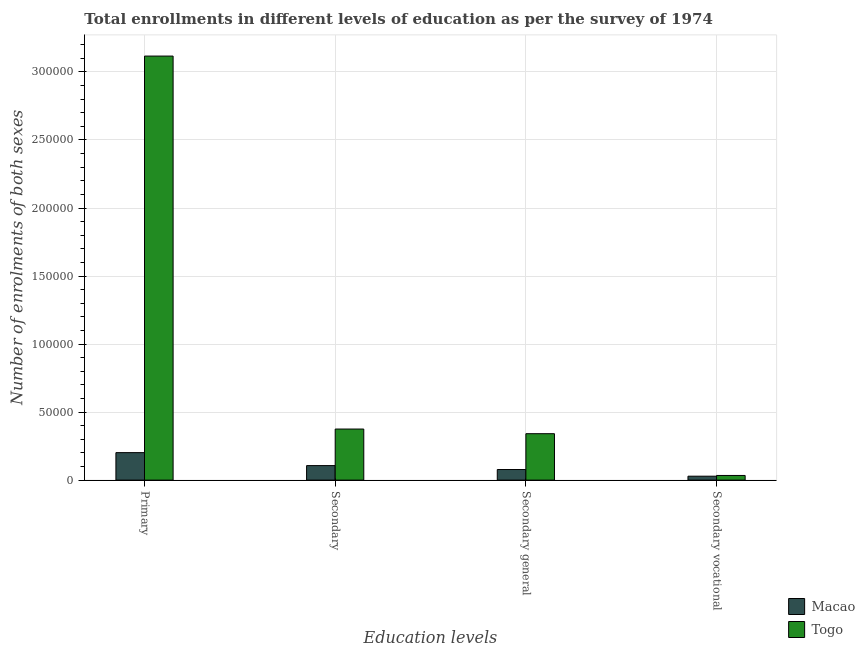How many groups of bars are there?
Offer a terse response. 4. Are the number of bars per tick equal to the number of legend labels?
Ensure brevity in your answer.  Yes. How many bars are there on the 4th tick from the right?
Keep it short and to the point. 2. What is the label of the 2nd group of bars from the left?
Your answer should be compact. Secondary. What is the number of enrolments in secondary vocational education in Togo?
Your answer should be very brief. 3421. Across all countries, what is the maximum number of enrolments in secondary vocational education?
Provide a short and direct response. 3421. Across all countries, what is the minimum number of enrolments in secondary education?
Your answer should be very brief. 1.07e+04. In which country was the number of enrolments in secondary education maximum?
Your answer should be compact. Togo. In which country was the number of enrolments in secondary general education minimum?
Give a very brief answer. Macao. What is the total number of enrolments in secondary education in the graph?
Provide a succinct answer. 4.82e+04. What is the difference between the number of enrolments in primary education in Macao and that in Togo?
Your answer should be very brief. -2.91e+05. What is the difference between the number of enrolments in secondary general education in Macao and the number of enrolments in secondary education in Togo?
Offer a terse response. -2.98e+04. What is the average number of enrolments in secondary vocational education per country?
Your answer should be compact. 3153. What is the difference between the number of enrolments in primary education and number of enrolments in secondary vocational education in Togo?
Give a very brief answer. 3.08e+05. In how many countries, is the number of enrolments in secondary vocational education greater than 270000 ?
Offer a very short reply. 0. What is the ratio of the number of enrolments in secondary vocational education in Macao to that in Togo?
Your response must be concise. 0.84. Is the number of enrolments in secondary general education in Togo less than that in Macao?
Keep it short and to the point. No. Is the difference between the number of enrolments in secondary general education in Macao and Togo greater than the difference between the number of enrolments in primary education in Macao and Togo?
Your answer should be compact. Yes. What is the difference between the highest and the second highest number of enrolments in secondary education?
Offer a terse response. 2.69e+04. What is the difference between the highest and the lowest number of enrolments in secondary general education?
Ensure brevity in your answer.  2.63e+04. What does the 2nd bar from the left in Primary represents?
Keep it short and to the point. Togo. What does the 2nd bar from the right in Secondary vocational represents?
Provide a short and direct response. Macao. Does the graph contain any zero values?
Provide a short and direct response. No. Where does the legend appear in the graph?
Offer a very short reply. Bottom right. How many legend labels are there?
Offer a very short reply. 2. How are the legend labels stacked?
Keep it short and to the point. Vertical. What is the title of the graph?
Keep it short and to the point. Total enrollments in different levels of education as per the survey of 1974. What is the label or title of the X-axis?
Your response must be concise. Education levels. What is the label or title of the Y-axis?
Ensure brevity in your answer.  Number of enrolments of both sexes. What is the Number of enrolments of both sexes in Macao in Primary?
Provide a succinct answer. 2.02e+04. What is the Number of enrolments of both sexes of Togo in Primary?
Your answer should be compact. 3.12e+05. What is the Number of enrolments of both sexes of Macao in Secondary?
Keep it short and to the point. 1.07e+04. What is the Number of enrolments of both sexes of Togo in Secondary?
Keep it short and to the point. 3.75e+04. What is the Number of enrolments of both sexes in Macao in Secondary general?
Provide a short and direct response. 7786. What is the Number of enrolments of both sexes of Togo in Secondary general?
Keep it short and to the point. 3.41e+04. What is the Number of enrolments of both sexes of Macao in Secondary vocational?
Your response must be concise. 2885. What is the Number of enrolments of both sexes of Togo in Secondary vocational?
Give a very brief answer. 3421. Across all Education levels, what is the maximum Number of enrolments of both sexes of Macao?
Provide a succinct answer. 2.02e+04. Across all Education levels, what is the maximum Number of enrolments of both sexes in Togo?
Make the answer very short. 3.12e+05. Across all Education levels, what is the minimum Number of enrolments of both sexes in Macao?
Provide a succinct answer. 2885. Across all Education levels, what is the minimum Number of enrolments of both sexes of Togo?
Give a very brief answer. 3421. What is the total Number of enrolments of both sexes of Macao in the graph?
Your answer should be very brief. 4.15e+04. What is the total Number of enrolments of both sexes of Togo in the graph?
Keep it short and to the point. 3.87e+05. What is the difference between the Number of enrolments of both sexes in Macao in Primary and that in Secondary?
Your answer should be compact. 9534. What is the difference between the Number of enrolments of both sexes of Togo in Primary and that in Secondary?
Give a very brief answer. 2.74e+05. What is the difference between the Number of enrolments of both sexes of Macao in Primary and that in Secondary general?
Offer a very short reply. 1.24e+04. What is the difference between the Number of enrolments of both sexes of Togo in Primary and that in Secondary general?
Provide a succinct answer. 2.78e+05. What is the difference between the Number of enrolments of both sexes in Macao in Primary and that in Secondary vocational?
Ensure brevity in your answer.  1.73e+04. What is the difference between the Number of enrolments of both sexes in Togo in Primary and that in Secondary vocational?
Offer a terse response. 3.08e+05. What is the difference between the Number of enrolments of both sexes of Macao in Secondary and that in Secondary general?
Your response must be concise. 2885. What is the difference between the Number of enrolments of both sexes of Togo in Secondary and that in Secondary general?
Give a very brief answer. 3421. What is the difference between the Number of enrolments of both sexes of Macao in Secondary and that in Secondary vocational?
Give a very brief answer. 7786. What is the difference between the Number of enrolments of both sexes in Togo in Secondary and that in Secondary vocational?
Give a very brief answer. 3.41e+04. What is the difference between the Number of enrolments of both sexes of Macao in Secondary general and that in Secondary vocational?
Offer a very short reply. 4901. What is the difference between the Number of enrolments of both sexes of Togo in Secondary general and that in Secondary vocational?
Keep it short and to the point. 3.07e+04. What is the difference between the Number of enrolments of both sexes in Macao in Primary and the Number of enrolments of both sexes in Togo in Secondary?
Provide a short and direct response. -1.73e+04. What is the difference between the Number of enrolments of both sexes of Macao in Primary and the Number of enrolments of both sexes of Togo in Secondary general?
Your answer should be compact. -1.39e+04. What is the difference between the Number of enrolments of both sexes of Macao in Primary and the Number of enrolments of both sexes of Togo in Secondary vocational?
Offer a terse response. 1.68e+04. What is the difference between the Number of enrolments of both sexes in Macao in Secondary and the Number of enrolments of both sexes in Togo in Secondary general?
Your answer should be compact. -2.35e+04. What is the difference between the Number of enrolments of both sexes of Macao in Secondary and the Number of enrolments of both sexes of Togo in Secondary vocational?
Make the answer very short. 7250. What is the difference between the Number of enrolments of both sexes in Macao in Secondary general and the Number of enrolments of both sexes in Togo in Secondary vocational?
Give a very brief answer. 4365. What is the average Number of enrolments of both sexes of Macao per Education levels?
Provide a succinct answer. 1.04e+04. What is the average Number of enrolments of both sexes of Togo per Education levels?
Your answer should be very brief. 9.67e+04. What is the difference between the Number of enrolments of both sexes of Macao and Number of enrolments of both sexes of Togo in Primary?
Provide a succinct answer. -2.91e+05. What is the difference between the Number of enrolments of both sexes of Macao and Number of enrolments of both sexes of Togo in Secondary?
Offer a terse response. -2.69e+04. What is the difference between the Number of enrolments of both sexes in Macao and Number of enrolments of both sexes in Togo in Secondary general?
Offer a terse response. -2.63e+04. What is the difference between the Number of enrolments of both sexes in Macao and Number of enrolments of both sexes in Togo in Secondary vocational?
Keep it short and to the point. -536. What is the ratio of the Number of enrolments of both sexes in Macao in Primary to that in Secondary?
Your answer should be very brief. 1.89. What is the ratio of the Number of enrolments of both sexes of Togo in Primary to that in Secondary?
Your response must be concise. 8.3. What is the ratio of the Number of enrolments of both sexes of Macao in Primary to that in Secondary general?
Provide a short and direct response. 2.6. What is the ratio of the Number of enrolments of both sexes of Togo in Primary to that in Secondary general?
Your response must be concise. 9.13. What is the ratio of the Number of enrolments of both sexes of Macao in Primary to that in Secondary vocational?
Offer a very short reply. 7. What is the ratio of the Number of enrolments of both sexes in Togo in Primary to that in Secondary vocational?
Provide a succinct answer. 91.11. What is the ratio of the Number of enrolments of both sexes of Macao in Secondary to that in Secondary general?
Your answer should be very brief. 1.37. What is the ratio of the Number of enrolments of both sexes in Togo in Secondary to that in Secondary general?
Give a very brief answer. 1.1. What is the ratio of the Number of enrolments of both sexes in Macao in Secondary to that in Secondary vocational?
Provide a short and direct response. 3.7. What is the ratio of the Number of enrolments of both sexes in Togo in Secondary to that in Secondary vocational?
Make the answer very short. 10.98. What is the ratio of the Number of enrolments of both sexes in Macao in Secondary general to that in Secondary vocational?
Provide a succinct answer. 2.7. What is the ratio of the Number of enrolments of both sexes in Togo in Secondary general to that in Secondary vocational?
Keep it short and to the point. 9.98. What is the difference between the highest and the second highest Number of enrolments of both sexes in Macao?
Make the answer very short. 9534. What is the difference between the highest and the second highest Number of enrolments of both sexes in Togo?
Provide a succinct answer. 2.74e+05. What is the difference between the highest and the lowest Number of enrolments of both sexes in Macao?
Ensure brevity in your answer.  1.73e+04. What is the difference between the highest and the lowest Number of enrolments of both sexes of Togo?
Provide a short and direct response. 3.08e+05. 